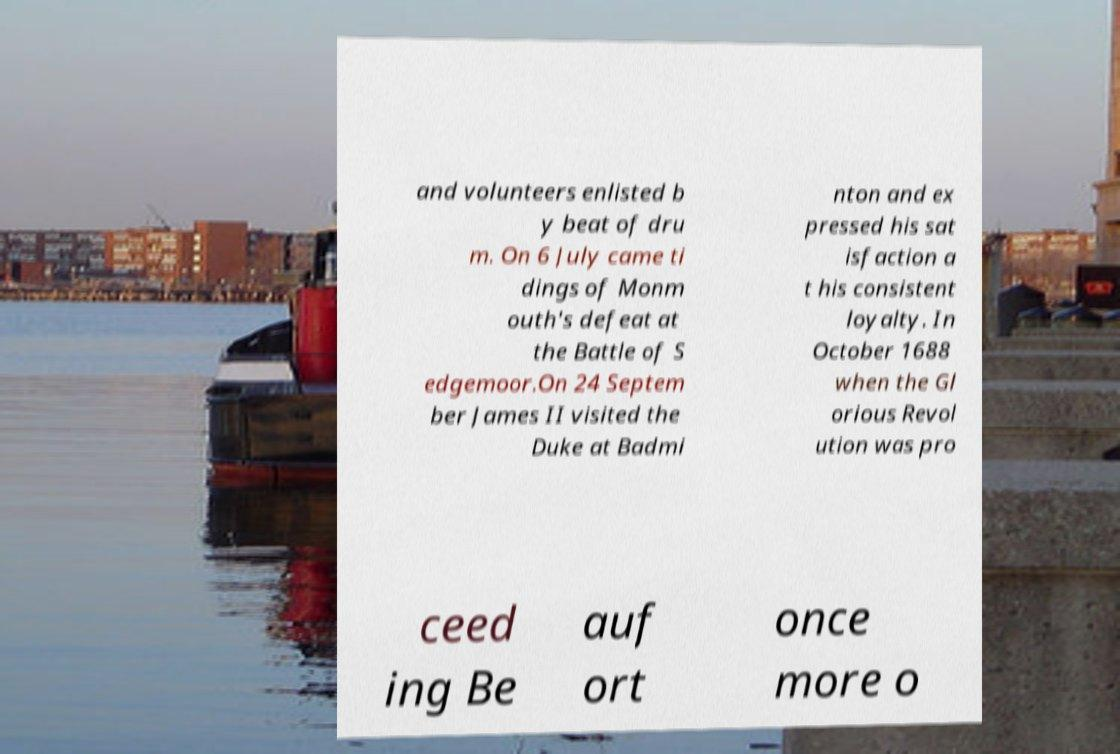For documentation purposes, I need the text within this image transcribed. Could you provide that? and volunteers enlisted b y beat of dru m. On 6 July came ti dings of Monm outh's defeat at the Battle of S edgemoor.On 24 Septem ber James II visited the Duke at Badmi nton and ex pressed his sat isfaction a t his consistent loyalty. In October 1688 when the Gl orious Revol ution was pro ceed ing Be auf ort once more o 